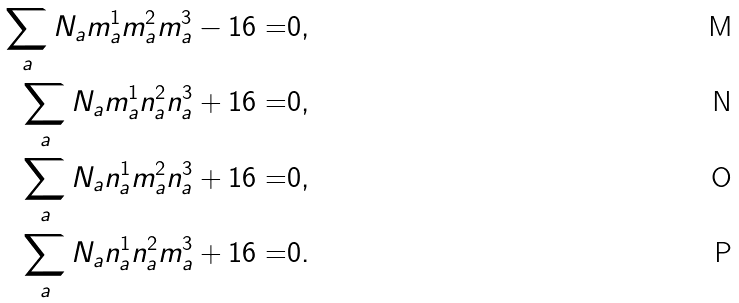Convert formula to latex. <formula><loc_0><loc_0><loc_500><loc_500>\sum _ { a } N _ { a } m _ { a } ^ { 1 } m _ { a } ^ { 2 } m _ { a } ^ { 3 } - 1 6 = & 0 , \\ \sum _ { a } N _ { a } m _ { a } ^ { 1 } n _ { a } ^ { 2 } n _ { a } ^ { 3 } + 1 6 = & 0 , \\ \sum _ { a } N _ { a } n _ { a } ^ { 1 } m _ { a } ^ { 2 } n _ { a } ^ { 3 } + 1 6 = & 0 , \\ \sum _ { a } N _ { a } n _ { a } ^ { 1 } n _ { a } ^ { 2 } m _ { a } ^ { 3 } + 1 6 = & 0 .</formula> 